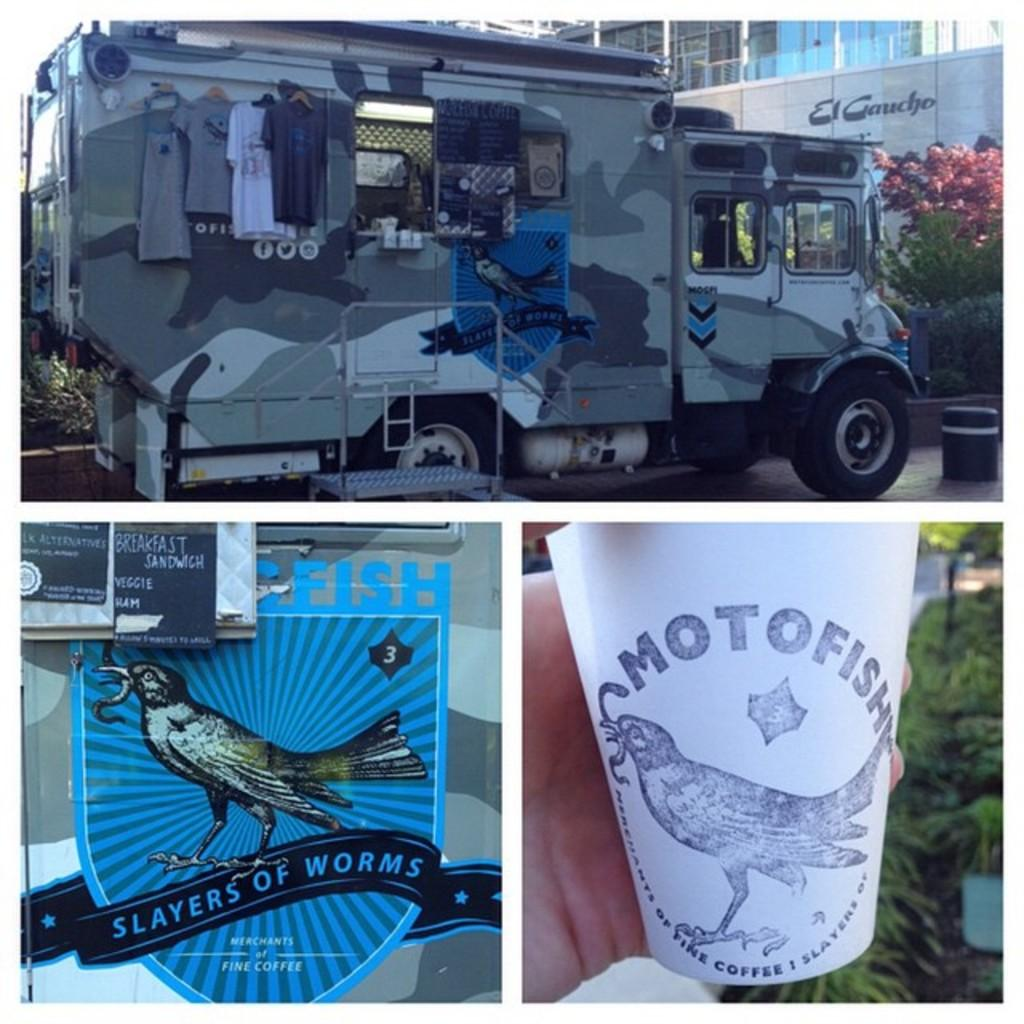<image>
Give a short and clear explanation of the subsequent image. Collage of photos with one showing a cup that says Motofish on it. 